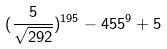Convert formula to latex. <formula><loc_0><loc_0><loc_500><loc_500>( \frac { 5 } { \sqrt { 2 9 2 } } ) ^ { 1 9 5 } - 4 5 5 ^ { 9 } + 5</formula> 